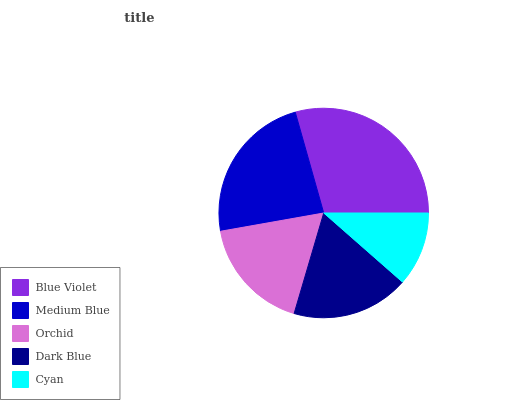Is Cyan the minimum?
Answer yes or no. Yes. Is Blue Violet the maximum?
Answer yes or no. Yes. Is Medium Blue the minimum?
Answer yes or no. No. Is Medium Blue the maximum?
Answer yes or no. No. Is Blue Violet greater than Medium Blue?
Answer yes or no. Yes. Is Medium Blue less than Blue Violet?
Answer yes or no. Yes. Is Medium Blue greater than Blue Violet?
Answer yes or no. No. Is Blue Violet less than Medium Blue?
Answer yes or no. No. Is Dark Blue the high median?
Answer yes or no. Yes. Is Dark Blue the low median?
Answer yes or no. Yes. Is Medium Blue the high median?
Answer yes or no. No. Is Medium Blue the low median?
Answer yes or no. No. 